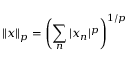<formula> <loc_0><loc_0><loc_500><loc_500>\| x \| _ { p } = \left ( \sum _ { n } | x _ { n } | ^ { p } \right ) ^ { 1 / p }</formula> 